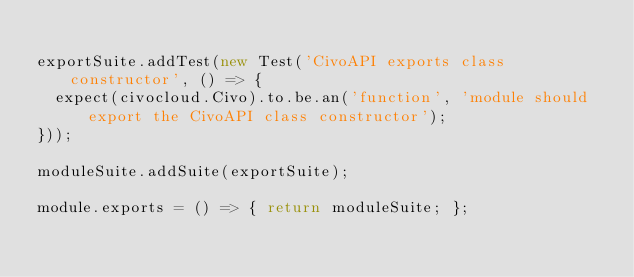Convert code to text. <code><loc_0><loc_0><loc_500><loc_500><_JavaScript_>
exportSuite.addTest(new Test('CivoAPI exports class constructor', () => {
  expect(civocloud.Civo).to.be.an('function', 'module should export the CivoAPI class constructor');
}));

moduleSuite.addSuite(exportSuite);

module.exports = () => { return moduleSuite; };
</code> 